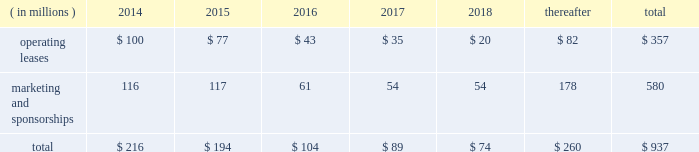Visa inc .
Notes to consolidated financial statements 2014 ( continued ) september 30 , 2013 market condition is based on the company 2019s total shareholder return ranked against that of other companies that are included in the standard & poor 2019s 500 index .
The fair value of the performance- based shares , incorporating the market condition , is estimated on the grant date using a monte carlo simulation model .
The grant-date fair value of performance-based shares in fiscal 2013 , 2012 and 2011 was $ 164.14 , $ 97.84 and $ 85.05 per share , respectively .
Earned performance shares granted in fiscal 2013 and 2012 vest approximately three years from the initial grant date .
Earned performance shares granted in fiscal 2011 vest in two equal installments approximately two and three years from their respective grant dates .
All performance awards are subject to earlier vesting in full under certain conditions .
Compensation cost for performance-based shares is initially estimated based on target performance .
It is recorded net of estimated forfeitures and adjusted as appropriate throughout the performance period .
At september 30 , 2013 , there was $ 15 million of total unrecognized compensation cost related to unvested performance-based shares , which is expected to be recognized over a weighted-average period of approximately 1.0 years .
Note 17 2014commitments and contingencies commitments .
The company leases certain premises and equipment throughout the world with varying expiration dates .
The company incurred total rent expense of $ 94 million , $ 89 million and $ 76 million in fiscal 2013 , 2012 and 2011 , respectively .
Future minimum payments on leases , and marketing and sponsorship agreements per fiscal year , at september 30 , 2013 , are as follows: .
Select sponsorship agreements require the company to spend certain minimum amounts for advertising and marketing promotion over the life of the contract .
For commitments where the individual years of spend are not specified in the contract , the company has estimated the timing of when these amounts will be spent .
In addition to the fixed payments stated above , select sponsorship agreements require the company to undertake marketing , promotional or other activities up to stated monetary values to support events which the company is sponsoring .
The stated monetary value of these activities typically represents the value in the marketplace , which may be significantly in excess of the actual costs incurred by the company .
Client incentives .
The company has agreements with financial institution clients and other business partners for various programs designed to build payments volume , increase visa-branded card and product acceptance and win merchant routing transactions .
These agreements , with original terms ranging from one to thirteen years , can provide card issuance and/or conversion support , volume/growth targets and marketing and program support based on specific performance requirements .
These agreements are designed to encourage client business and to increase overall visa-branded payment and transaction volume , thereby reducing per-unit transaction processing costs and increasing brand awareness for all visa clients .
Payments made that qualify for capitalization , and obligations incurred under these programs are reflected on the consolidated balance sheet .
Client incentives are recognized primarily as a reduction .
In 2013 what was the percent of the future minimum payments on leases , and marketing and sponsorship for operating leases that was due in? 
Computations: (35 / 357)
Answer: 0.09804. 